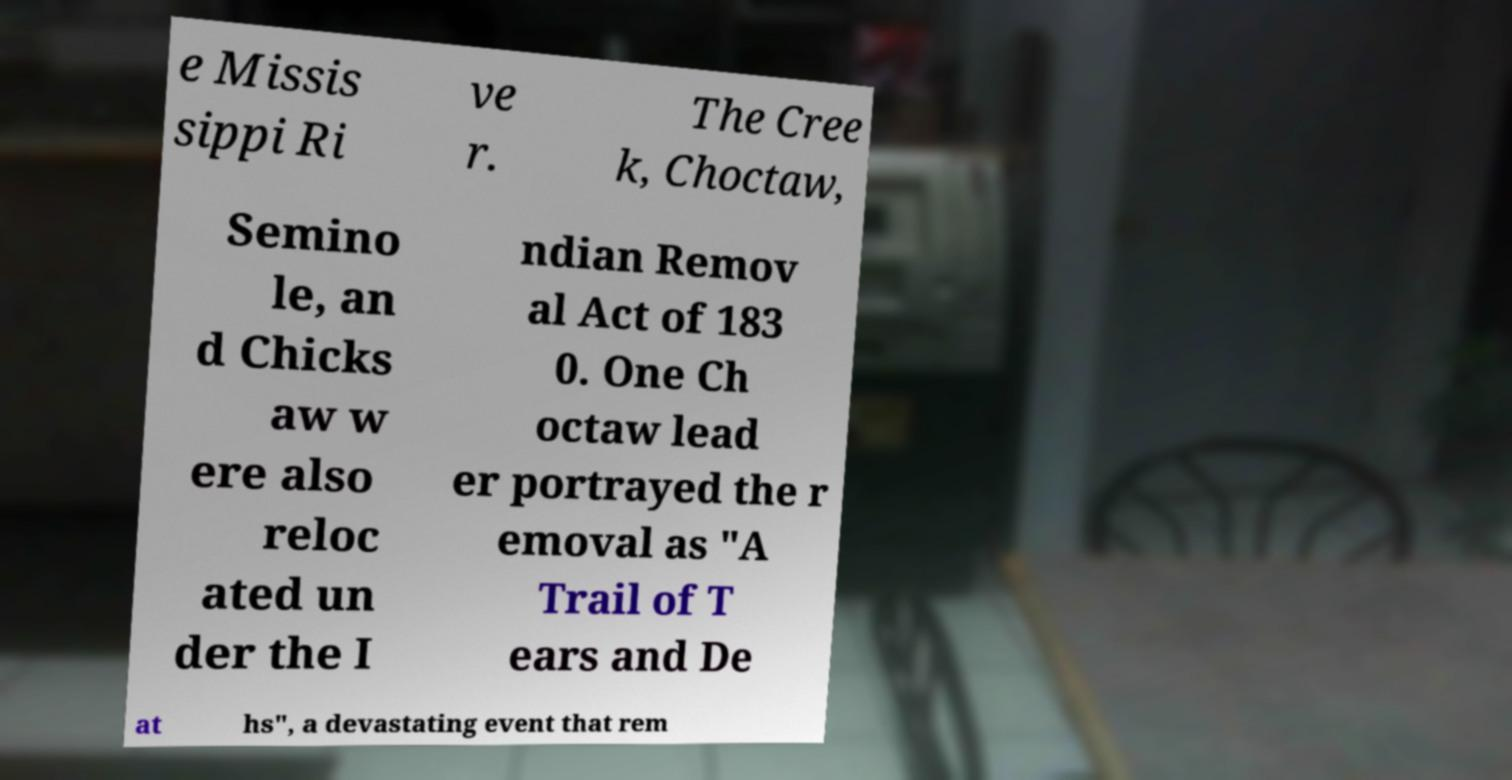What messages or text are displayed in this image? I need them in a readable, typed format. e Missis sippi Ri ve r. The Cree k, Choctaw, Semino le, an d Chicks aw w ere also reloc ated un der the I ndian Remov al Act of 183 0. One Ch octaw lead er portrayed the r emoval as "A Trail of T ears and De at hs", a devastating event that rem 